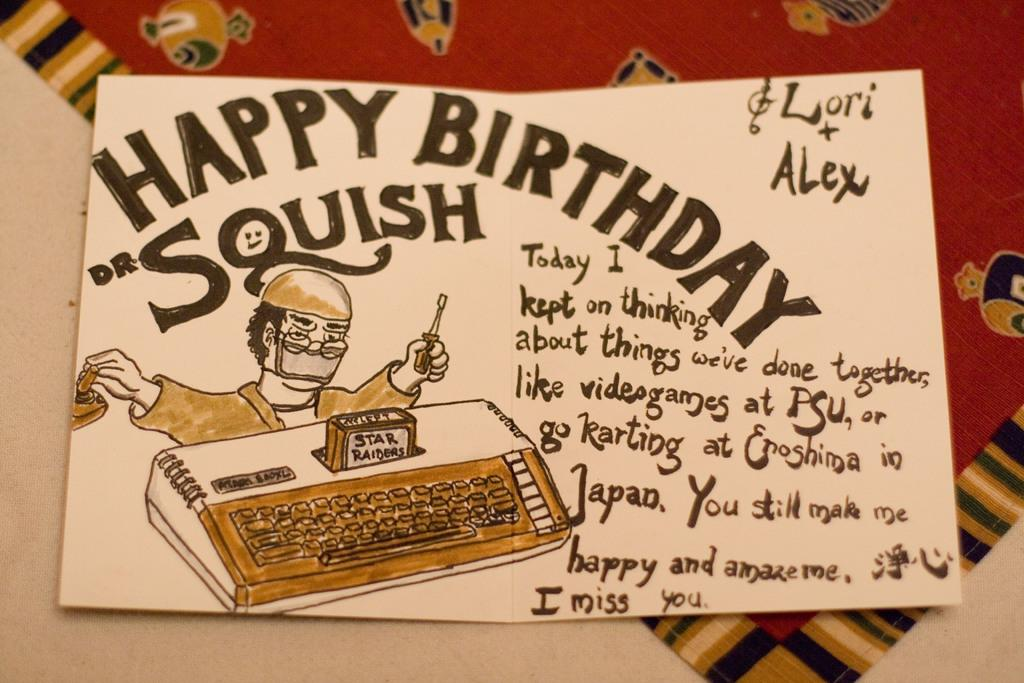<image>
Present a compact description of the photo's key features. Postcard from Lori and Alex, wishing Dr. Squish a happy birthday. 